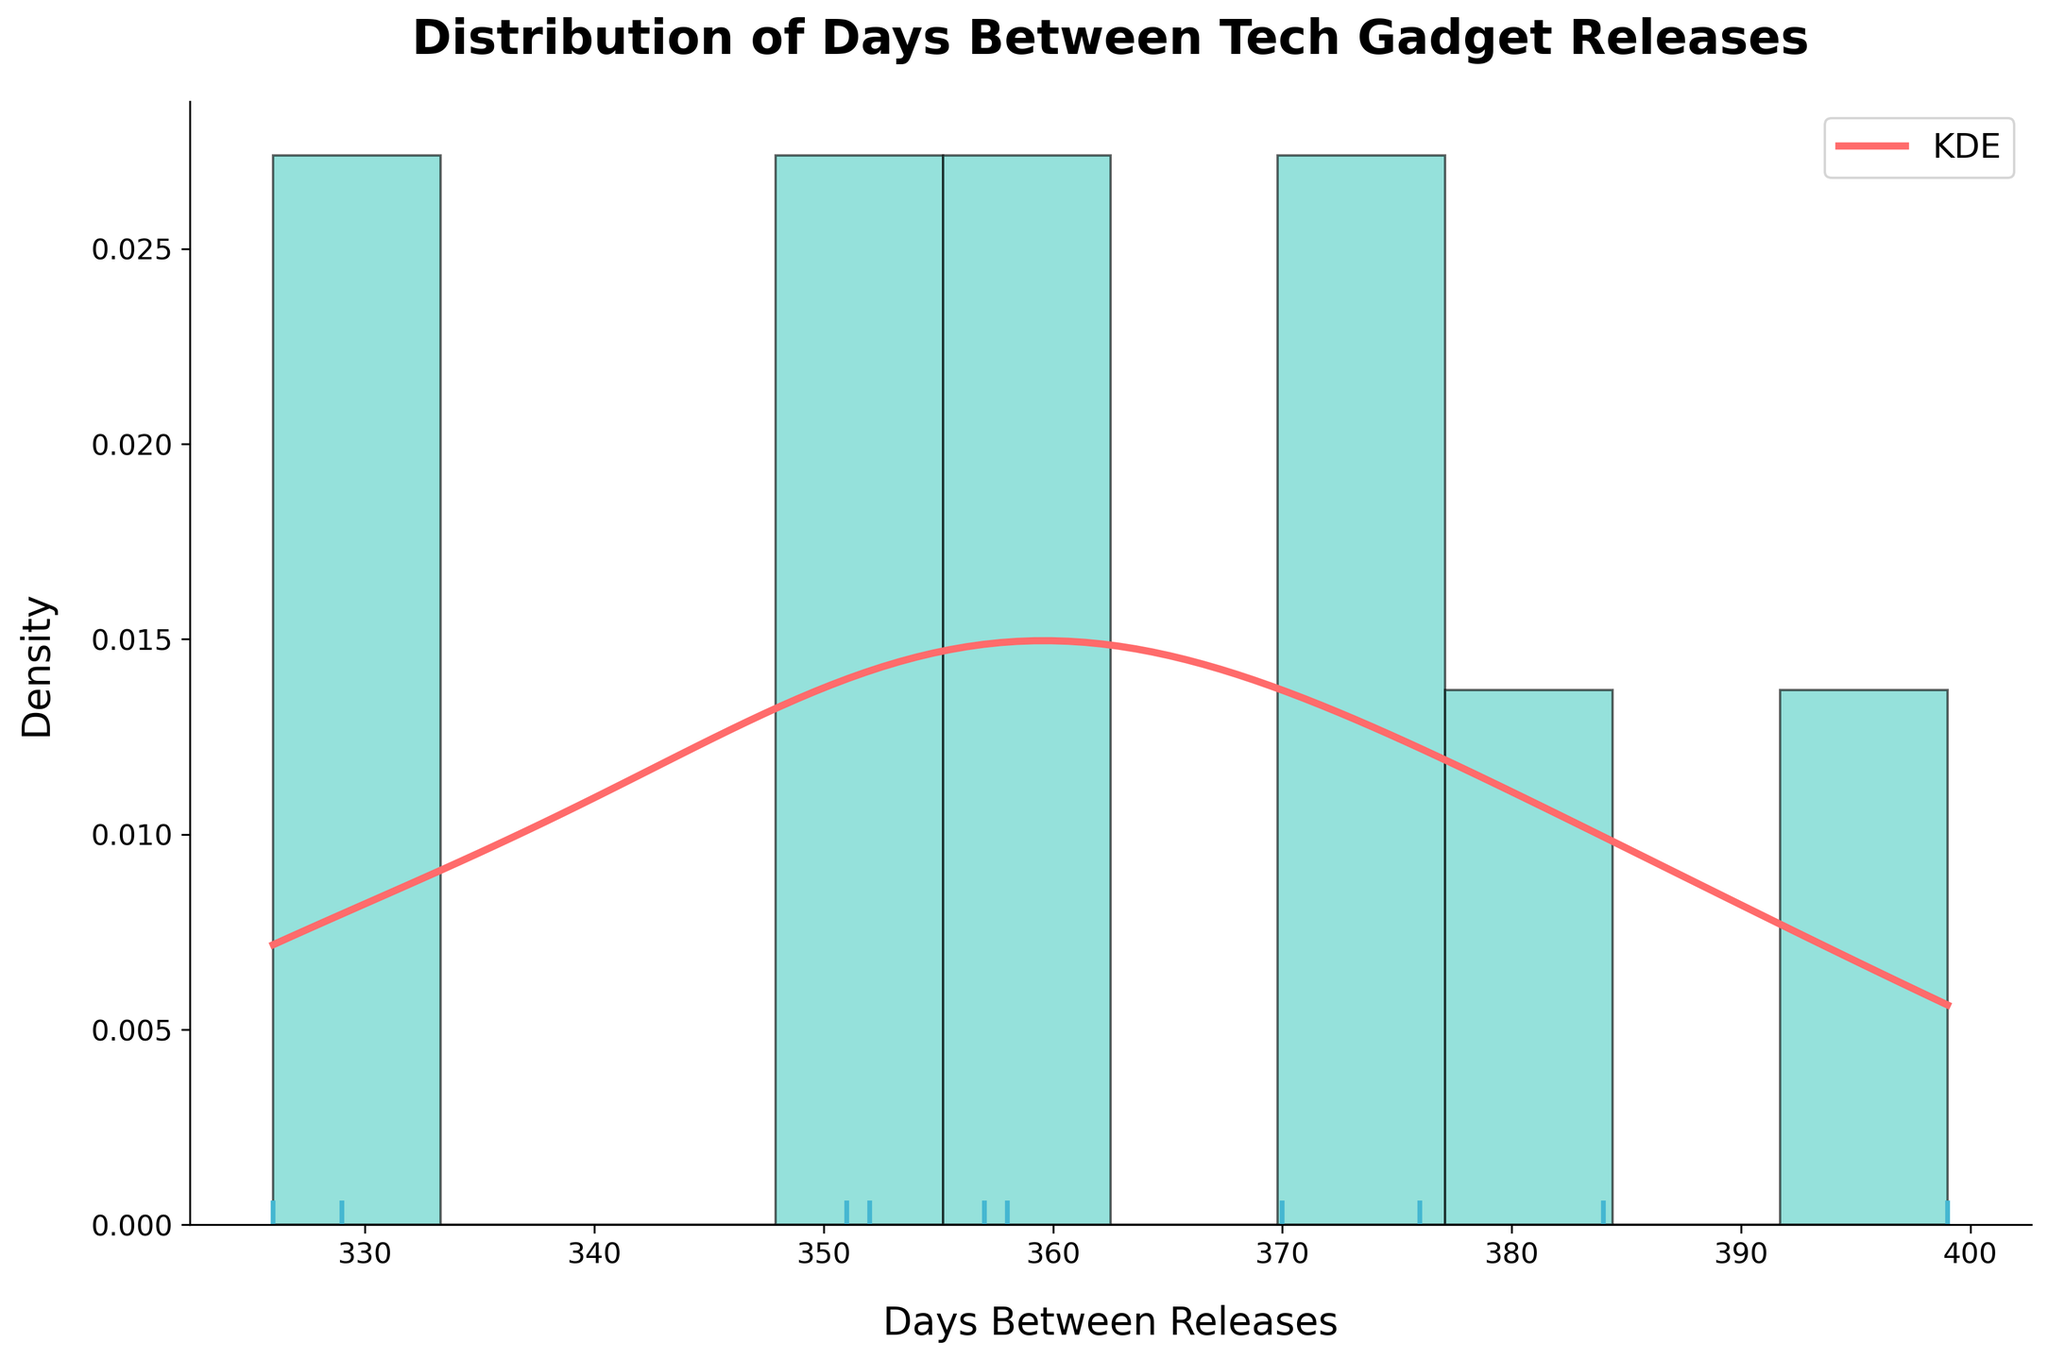What is the title of the plot? The title is displayed prominently at the top of the plot. By reading it, we can understand the main topic or focus of the visualized data.
Answer: Distribution of Days Between Tech Gadget Releases What does the x-axis represent? The label on the x-axis indicates what the data values on this axis represent. In this case, it represents the "Days Between Releases".
Answer: Days Between Releases How many bins are there in the histogram? By counting the number of rectangular bars in the histogram portion of the plot, we can determine the number of bins used. There are 10 bins visible.
Answer: 10 What color is used for the histogram bars? The color of the histogram bars is visible and can be identified by looking at the plot. The bars are colored in a light blue-green shade.
Answer: Light blue-green What is the peak density value on the KDE line? By observing the height of the KDE line, we can identify its peak density value, which is the highest point on the KDE curve. This value looks around 0.004 from visual inspection.
Answer: Around 0.004 Which product has the shortest time between releases? By observing the rug plot at the bottom, the markers at the shortest distance from 0 indicate the shortest time. According to the dataset, it is the Samsung Galaxy S20.
Answer: Samsung Galaxy S20 Which product has the longest time between releases? By checking the markers on the rug plot and referencing the dataset, we find that the iPhone 14 has the longest interval.
Answer: iPhone 14 What's the average number of days between releases? To determine the average, calculate the mean of all intervals shown. From the plot, it appears centered around 365 days, equivalent to approximately a year.
Answer: Around 365 days Are there more intervals below or above 400 days? By comparing the areas under the histogram and KDE curve on either side of 400 days, it is evident which side has more intervals. There are more intervals below 400 days.
Answer: Below 400 days Is the distribution of days between releases symmetric? Symmetry in the distribution would make the plot look mirror-like on either side of the center. The distribution appears mildly skewed and not perfectly symmetric.
Answer: No 